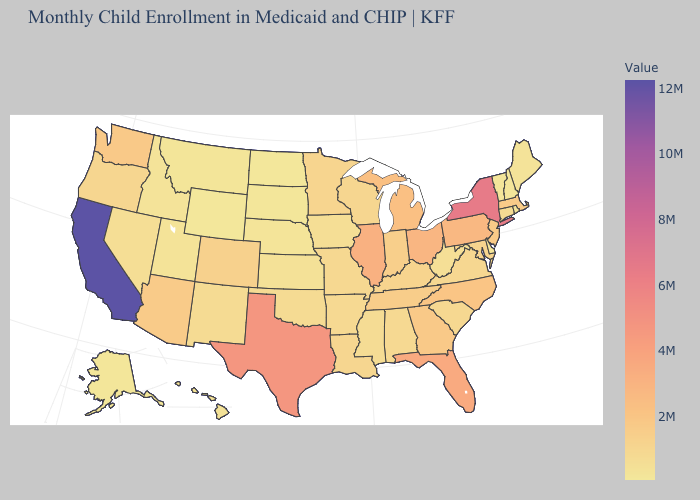Is the legend a continuous bar?
Answer briefly. Yes. Does Idaho have the highest value in the West?
Keep it brief. No. 